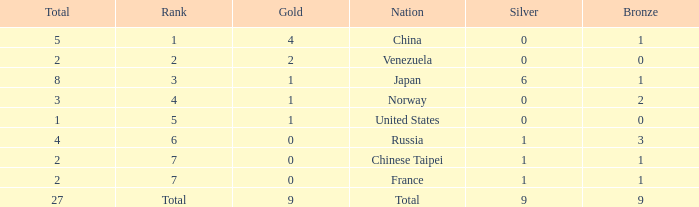What is the Nation when there is a total less than 27, gold is less than 1, and bronze is more than 1? Russia. Can you give me this table as a dict? {'header': ['Total', 'Rank', 'Gold', 'Nation', 'Silver', 'Bronze'], 'rows': [['5', '1', '4', 'China', '0', '1'], ['2', '2', '2', 'Venezuela', '0', '0'], ['8', '3', '1', 'Japan', '6', '1'], ['3', '4', '1', 'Norway', '0', '2'], ['1', '5', '1', 'United States', '0', '0'], ['4', '6', '0', 'Russia', '1', '3'], ['2', '7', '0', 'Chinese Taipei', '1', '1'], ['2', '7', '0', 'France', '1', '1'], ['27', 'Total', '9', 'Total', '9', '9']]} 